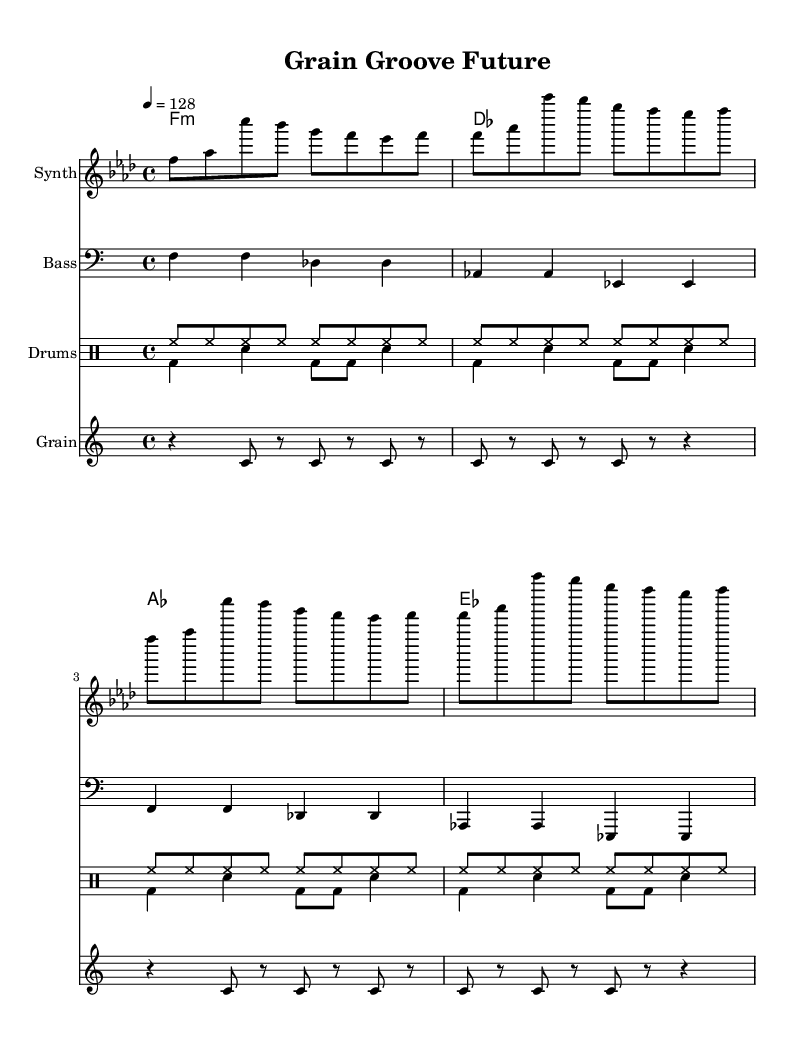What is the key signature of this music? The key signature indicates the notes to be played sharp or flat. In this piece, the key is F minor, which contains four flats (B, E, A, D). It can be confirmed by looking at the key signature placed at the beginning of the staff.
Answer: F minor What is the time signature of this music? The time signature indicates how many beats are in each measure and which note value is counted as a beat. In this score, the time signature is 4/4, meaning there are four beats in each measure, and the quarter note gets one beat. This is indicated at the beginning of the score.
Answer: 4/4 What is the tempo marking for this piece? The tempo marking shows how fast the piece should be played. The marking indicates a speed of 128 beats per minute, which is expressed as "4 = 128" at the start of the score.
Answer: 128 How many measures does the melody section contain? The melody section consists of repeated eight measures. This can be assessed by counting the bars represented in the melody line, which is repeated four times as evidenced by the structure of the melody.
Answer: 8 What is the main rhythmic component in the drum section? The main rhythmic component in the drum section is the hi-hat pattern played in eighth notes throughout, which creates a steady pulse. The drums are marked with "hh" for hi-hat in the quick rhythmic pattern.
Answer: Hi-hat Which instrument plays the grain samples in the composition? The score specifies that the "Grain" staff plays the grain samples. This indicates a sound or rhythm that is inspired by cereal grain elements and is included in the overall texture of the piece.
Answer: Grain What type of chords are primarily used in the harmony section? The harmony section primarily utilizes minor chords, as seen from the chord names specified which include F minor, D flat major, A flat major, and E flat major. This choice of chords enhances the overall darker mood of the piece.
Answer: Minor 